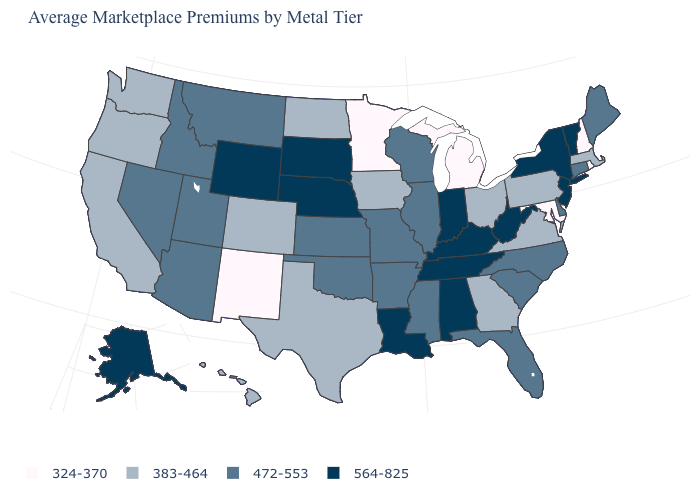Name the states that have a value in the range 383-464?
Answer briefly. California, Colorado, Georgia, Hawaii, Iowa, Massachusetts, North Dakota, Ohio, Oregon, Pennsylvania, Texas, Virginia, Washington. Name the states that have a value in the range 324-370?
Be succinct. Maryland, Michigan, Minnesota, New Hampshire, New Mexico, Rhode Island. What is the value of Idaho?
Quick response, please. 472-553. Among the states that border Connecticut , which have the highest value?
Be succinct. New York. Does the first symbol in the legend represent the smallest category?
Answer briefly. Yes. What is the value of Massachusetts?
Answer briefly. 383-464. Name the states that have a value in the range 564-825?
Quick response, please. Alabama, Alaska, Indiana, Kentucky, Louisiana, Nebraska, New Jersey, New York, South Dakota, Tennessee, Vermont, West Virginia, Wyoming. Which states have the highest value in the USA?
Give a very brief answer. Alabama, Alaska, Indiana, Kentucky, Louisiana, Nebraska, New Jersey, New York, South Dakota, Tennessee, Vermont, West Virginia, Wyoming. What is the value of North Carolina?
Answer briefly. 472-553. Name the states that have a value in the range 383-464?
Write a very short answer. California, Colorado, Georgia, Hawaii, Iowa, Massachusetts, North Dakota, Ohio, Oregon, Pennsylvania, Texas, Virginia, Washington. Name the states that have a value in the range 472-553?
Give a very brief answer. Arizona, Arkansas, Connecticut, Delaware, Florida, Idaho, Illinois, Kansas, Maine, Mississippi, Missouri, Montana, Nevada, North Carolina, Oklahoma, South Carolina, Utah, Wisconsin. What is the highest value in the West ?
Write a very short answer. 564-825. Does Massachusetts have the same value as North Dakota?
Write a very short answer. Yes. Name the states that have a value in the range 383-464?
Short answer required. California, Colorado, Georgia, Hawaii, Iowa, Massachusetts, North Dakota, Ohio, Oregon, Pennsylvania, Texas, Virginia, Washington. What is the lowest value in states that border Oklahoma?
Short answer required. 324-370. 